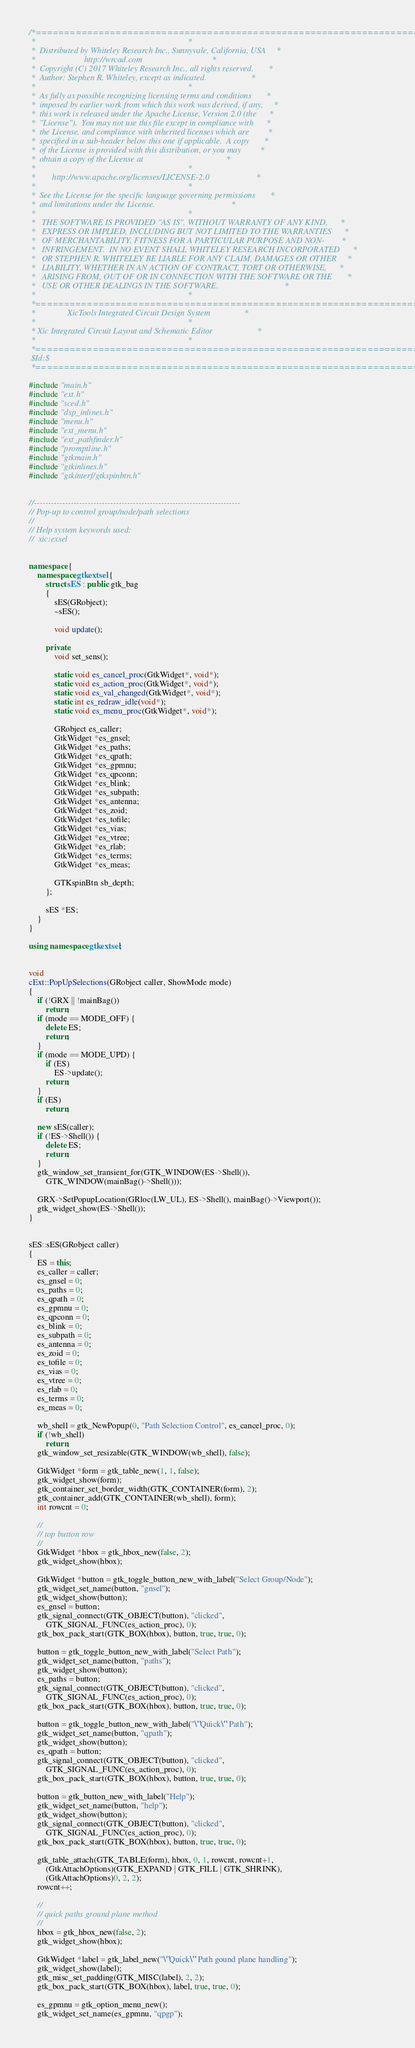Convert code to text. <code><loc_0><loc_0><loc_500><loc_500><_C++_>
/*========================================================================*
 *                                                                        *
 *  Distributed by Whiteley Research Inc., Sunnyvale, California, USA     *
 *                       http://wrcad.com                                 *
 *  Copyright (C) 2017 Whiteley Research Inc., all rights reserved.       *
 *  Author: Stephen R. Whiteley, except as indicated.                     *
 *                                                                        *
 *  As fully as possible recognizing licensing terms and conditions       *
 *  imposed by earlier work from which this work was derived, if any,     *
 *  this work is released under the Apache License, Version 2.0 (the      *
 *  "License").  You may not use this file except in compliance with      *
 *  the License, and compliance with inherited licenses which are         *
 *  specified in a sub-header below this one if applicable.  A copy       *
 *  of the License is provided with this distribution, or you may         *
 *  obtain a copy of the License at                                       *
 *                                                                        *
 *        http://www.apache.org/licenses/LICENSE-2.0                      *
 *                                                                        *
 *  See the License for the specific language governing permissions       *
 *  and limitations under the License.                                    *
 *                                                                        *
 *   THE SOFTWARE IS PROVIDED "AS IS", WITHOUT WARRANTY OF ANY KIND,      *
 *   EXPRESS OR IMPLIED, INCLUDING BUT NOT LIMITED TO THE WARRANTIES      *
 *   OF MERCHANTABILITY, FITNESS FOR A PARTICULAR PURPOSE AND NON-        *
 *   INFRINGEMENT.  IN NO EVENT SHALL WHITELEY RESEARCH INCORPORATED      *
 *   OR STEPHEN R. WHITELEY BE LIABLE FOR ANY CLAIM, DAMAGES OR OTHER     *
 *   LIABILITY, WHETHER IN AN ACTION OF CONTRACT, TORT OR OTHERWISE,      *
 *   ARISING FROM, OUT OF OR IN CONNECTION WITH THE SOFTWARE OR THE       *
 *   USE OR OTHER DEALINGS IN THE SOFTWARE.                               *
 *                                                                        *
 *========================================================================*
 *               XicTools Integrated Circuit Design System                *
 *                                                                        *
 * Xic Integrated Circuit Layout and Schematic Editor                     *
 *                                                                        *
 *========================================================================*
 $Id:$
 *========================================================================*/

#include "main.h"
#include "ext.h"
#include "sced.h"
#include "dsp_inlines.h"
#include "menu.h"
#include "ext_menu.h"
#include "ext_pathfinder.h"
#include "promptline.h"
#include "gtkmain.h"
#include "gtkinlines.h"
#include "gtkinterf/gtkspinbtn.h"


//-------------------------------------------------------------------------
// Pop-up to control group/node/path selections
//
// Help system keywords used:
//  xic:exsel


namespace {
    namespace gtkextsel {
        struct sES : public gtk_bag
        {
            sES(GRobject);
            ~sES();

            void update();

        private:
            void set_sens();

            static void es_cancel_proc(GtkWidget*, void*);
            static void es_action_proc(GtkWidget*, void*);
            static void es_val_changed(GtkWidget*, void*);
            static int es_redraw_idle(void*);
            static void es_menu_proc(GtkWidget*, void*);

            GRobject es_caller;
            GtkWidget *es_gnsel;
            GtkWidget *es_paths;
            GtkWidget *es_qpath;
            GtkWidget *es_gpmnu;
            GtkWidget *es_qpconn;
            GtkWidget *es_blink;
            GtkWidget *es_subpath;
            GtkWidget *es_antenna;
            GtkWidget *es_zoid;
            GtkWidget *es_tofile;
            GtkWidget *es_vias;
            GtkWidget *es_vtree;
            GtkWidget *es_rlab;
            GtkWidget *es_terms;
            GtkWidget *es_meas;

            GTKspinBtn sb_depth;
        };

        sES *ES;
    }
}

using namespace gtkextsel;


void
cExt::PopUpSelections(GRobject caller, ShowMode mode)
{
    if (!GRX || !mainBag())
        return;
    if (mode == MODE_OFF) {
        delete ES;
        return;
    }
    if (mode == MODE_UPD) {
        if (ES)
            ES->update();
        return;
    }
    if (ES)
        return;

    new sES(caller);
    if (!ES->Shell()) {
        delete ES;
        return;
    }
    gtk_window_set_transient_for(GTK_WINDOW(ES->Shell()),
        GTK_WINDOW(mainBag()->Shell()));

    GRX->SetPopupLocation(GRloc(LW_UL), ES->Shell(), mainBag()->Viewport());
    gtk_widget_show(ES->Shell());
}


sES::sES(GRobject caller)
{
    ES = this;
    es_caller = caller;
    es_gnsel = 0;
    es_paths = 0;
    es_qpath = 0;
    es_gpmnu = 0;
    es_qpconn = 0;
    es_blink = 0;
    es_subpath = 0;
    es_antenna = 0;
    es_zoid = 0;
    es_tofile = 0;
    es_vias = 0;
    es_vtree = 0;
    es_rlab = 0;
    es_terms = 0;
    es_meas = 0;

    wb_shell = gtk_NewPopup(0, "Path Selection Control", es_cancel_proc, 0);
    if (!wb_shell)
        return;
    gtk_window_set_resizable(GTK_WINDOW(wb_shell), false);

    GtkWidget *form = gtk_table_new(1, 1, false);
    gtk_widget_show(form);
    gtk_container_set_border_width(GTK_CONTAINER(form), 2);
    gtk_container_add(GTK_CONTAINER(wb_shell), form);
    int rowcnt = 0;

    //
    // top button row
    //
    GtkWidget *hbox = gtk_hbox_new(false, 2);
    gtk_widget_show(hbox);

    GtkWidget *button = gtk_toggle_button_new_with_label("Select Group/Node");
    gtk_widget_set_name(button, "gnsel");
    gtk_widget_show(button);
    es_gnsel = button;
    gtk_signal_connect(GTK_OBJECT(button), "clicked",
        GTK_SIGNAL_FUNC(es_action_proc), 0);
    gtk_box_pack_start(GTK_BOX(hbox), button, true, true, 0);

    button = gtk_toggle_button_new_with_label("Select Path");
    gtk_widget_set_name(button, "paths");
    gtk_widget_show(button);
    es_paths = button;
    gtk_signal_connect(GTK_OBJECT(button), "clicked",
        GTK_SIGNAL_FUNC(es_action_proc), 0);
    gtk_box_pack_start(GTK_BOX(hbox), button, true, true, 0);

    button = gtk_toggle_button_new_with_label("\"Quick\" Path");
    gtk_widget_set_name(button, "qpath");
    gtk_widget_show(button);
    es_qpath = button;
    gtk_signal_connect(GTK_OBJECT(button), "clicked",
        GTK_SIGNAL_FUNC(es_action_proc), 0);
    gtk_box_pack_start(GTK_BOX(hbox), button, true, true, 0);

    button = gtk_button_new_with_label("Help");
    gtk_widget_set_name(button, "help");
    gtk_widget_show(button);
    gtk_signal_connect(GTK_OBJECT(button), "clicked",
        GTK_SIGNAL_FUNC(es_action_proc), 0);
    gtk_box_pack_start(GTK_BOX(hbox), button, true, true, 0);

    gtk_table_attach(GTK_TABLE(form), hbox, 0, 1, rowcnt, rowcnt+1,
        (GtkAttachOptions)(GTK_EXPAND | GTK_FILL | GTK_SHRINK),
        (GtkAttachOptions)0, 2, 2);
    rowcnt++;

    //
    // quick paths ground plane method
    //
    hbox = gtk_hbox_new(false, 2);
    gtk_widget_show(hbox);

    GtkWidget *label = gtk_label_new("\"Quick\" Path gound plane handling");
    gtk_widget_show(label);
    gtk_misc_set_padding(GTK_MISC(label), 2, 2);
    gtk_box_pack_start(GTK_BOX(hbox), label, true, true, 0);

    es_gpmnu = gtk_option_menu_new();
    gtk_widget_set_name(es_gpmnu, "qpgp");</code> 